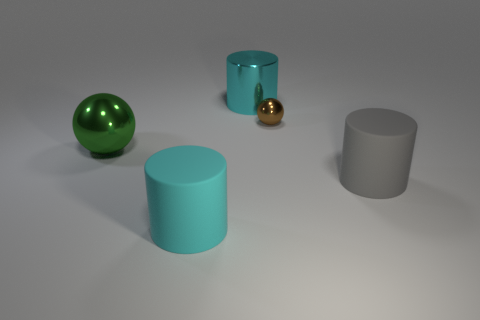Subtract all big gray cylinders. How many cylinders are left? 2 Add 1 tiny brown balls. How many objects exist? 6 Subtract all gray cylinders. How many cylinders are left? 2 Subtract all spheres. How many objects are left? 3 Subtract 1 brown spheres. How many objects are left? 4 Subtract 2 spheres. How many spheres are left? 0 Subtract all blue cylinders. Subtract all yellow blocks. How many cylinders are left? 3 Subtract all red cubes. How many green spheres are left? 1 Subtract all large metal cylinders. Subtract all cylinders. How many objects are left? 1 Add 5 brown spheres. How many brown spheres are left? 6 